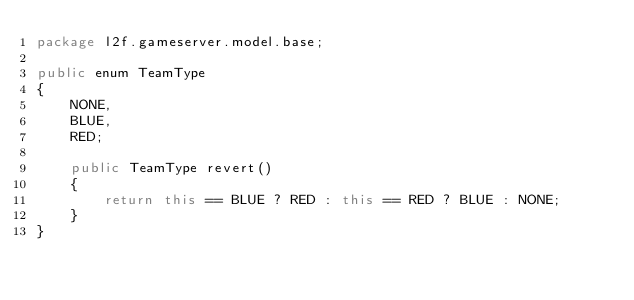Convert code to text. <code><loc_0><loc_0><loc_500><loc_500><_Java_>package l2f.gameserver.model.base;

public enum TeamType
{
	NONE,
	BLUE,
	RED;

	public TeamType revert()
	{
		return this == BLUE ? RED : this == RED ? BLUE : NONE;
	}
}
</code> 